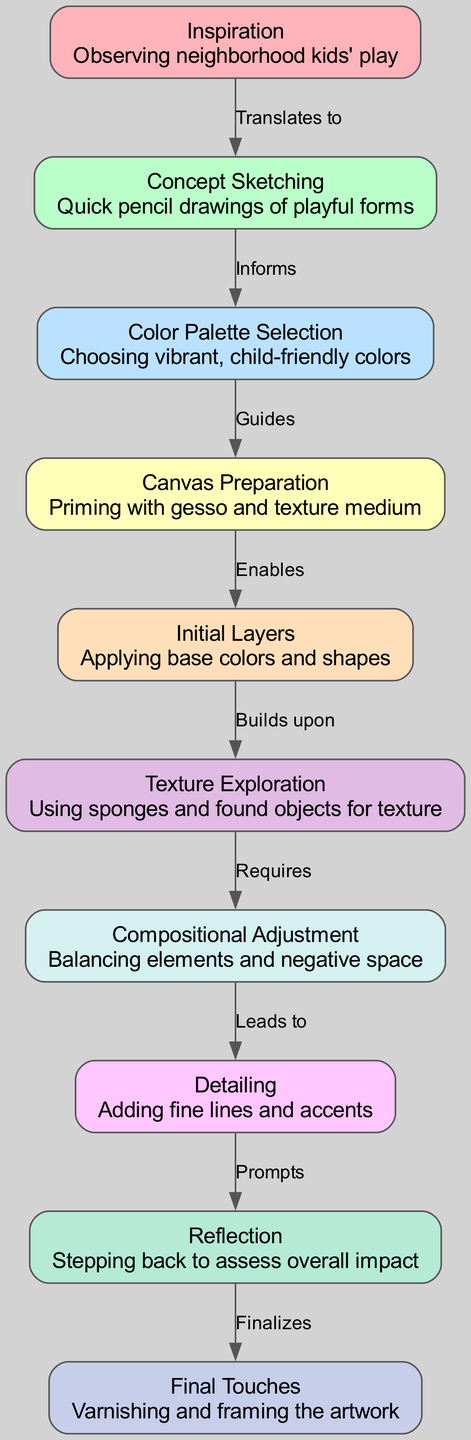What is the first stage in the creative process? The diagram shows "Inspiration" as the first node, indicating it's the starting point of the creative process.
Answer: Inspiration How many nodes are there in the diagram? By counting the nodes listed, there are a total of ten distinct stages in the creative process of abstract painting.
Answer: 10 Which node comes after “Initial Layers”? The diagram indicates that “Texture Exploration” is the next step following “Initial Layers,” as it is directly connected to it.
Answer: Texture Exploration What relationship does "Concept Sketching" have with other nodes? "Concept Sketching" is linked to "Inspiration" through the edge labeled "Translates to," and it informs "Color Palette Selection," showing its influence in the process.
Answer: Informs What does the label between "Detailing" and "Reflection" signify? The edge labeled "Prompts" between these two nodes indicates that detailing leads to a reflection phase, where the artist assesses their work.
Answer: Prompts Which two nodes are connected directly by an edge labeled “Requires”? The edge labeled “Requires” connects "Texture Exploration" and “Compositional Adjustment," indicating that compositional adjustment is necessary after texture exploration.
Answer: Texture Exploration and Compositional Adjustment What stage comes before the final artwork? The diagram denotes “Final Touches” as the conclusive stage following the reflection, indicating the last steps before the artwork is completed.
Answer: Final Touches What stage follows “Color Palette Selection”? According to the diagram, "Canvas Preparation" is the subsequent stage after "Color Palette Selection," highlighting the progression in the creative process.
Answer: Canvas Preparation Which process stage involves the choice of colors? The node named "Color Palette Selection" specifically states the act of choosing colors, confirming its role in the process.
Answer: Color Palette Selection 